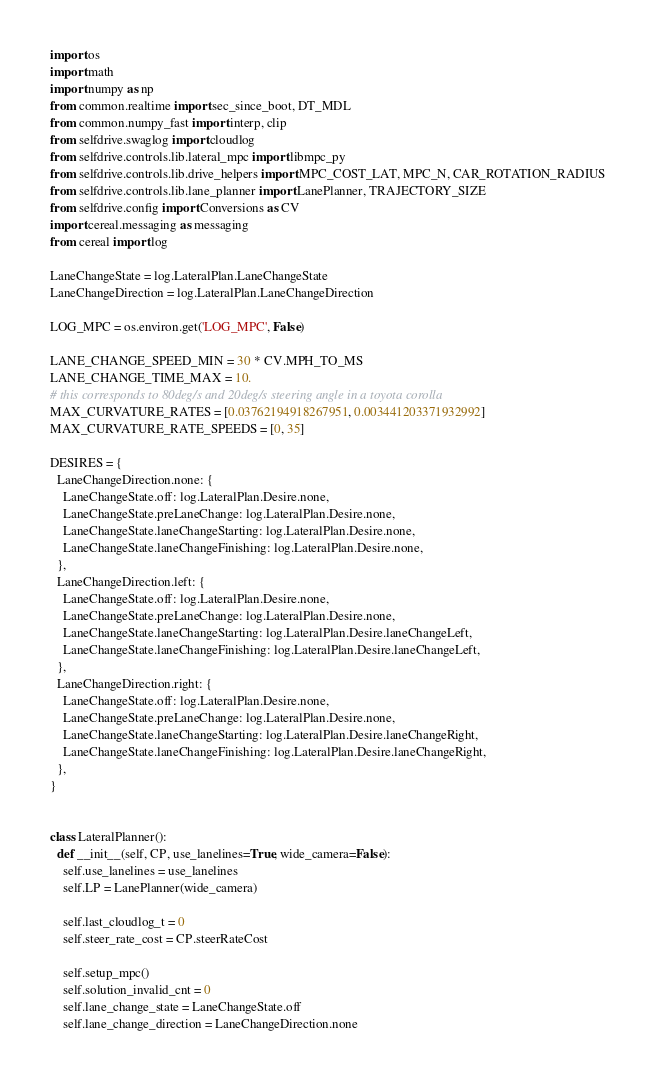Convert code to text. <code><loc_0><loc_0><loc_500><loc_500><_Python_>import os
import math
import numpy as np
from common.realtime import sec_since_boot, DT_MDL
from common.numpy_fast import interp, clip
from selfdrive.swaglog import cloudlog
from selfdrive.controls.lib.lateral_mpc import libmpc_py
from selfdrive.controls.lib.drive_helpers import MPC_COST_LAT, MPC_N, CAR_ROTATION_RADIUS
from selfdrive.controls.lib.lane_planner import LanePlanner, TRAJECTORY_SIZE
from selfdrive.config import Conversions as CV
import cereal.messaging as messaging
from cereal import log

LaneChangeState = log.LateralPlan.LaneChangeState
LaneChangeDirection = log.LateralPlan.LaneChangeDirection

LOG_MPC = os.environ.get('LOG_MPC', False)

LANE_CHANGE_SPEED_MIN = 30 * CV.MPH_TO_MS
LANE_CHANGE_TIME_MAX = 10.
# this corresponds to 80deg/s and 20deg/s steering angle in a toyota corolla
MAX_CURVATURE_RATES = [0.03762194918267951, 0.003441203371932992]
MAX_CURVATURE_RATE_SPEEDS = [0, 35]

DESIRES = {
  LaneChangeDirection.none: {
    LaneChangeState.off: log.LateralPlan.Desire.none,
    LaneChangeState.preLaneChange: log.LateralPlan.Desire.none,
    LaneChangeState.laneChangeStarting: log.LateralPlan.Desire.none,
    LaneChangeState.laneChangeFinishing: log.LateralPlan.Desire.none,
  },
  LaneChangeDirection.left: {
    LaneChangeState.off: log.LateralPlan.Desire.none,
    LaneChangeState.preLaneChange: log.LateralPlan.Desire.none,
    LaneChangeState.laneChangeStarting: log.LateralPlan.Desire.laneChangeLeft,
    LaneChangeState.laneChangeFinishing: log.LateralPlan.Desire.laneChangeLeft,
  },
  LaneChangeDirection.right: {
    LaneChangeState.off: log.LateralPlan.Desire.none,
    LaneChangeState.preLaneChange: log.LateralPlan.Desire.none,
    LaneChangeState.laneChangeStarting: log.LateralPlan.Desire.laneChangeRight,
    LaneChangeState.laneChangeFinishing: log.LateralPlan.Desire.laneChangeRight,
  },
}


class LateralPlanner():
  def __init__(self, CP, use_lanelines=True, wide_camera=False):
    self.use_lanelines = use_lanelines
    self.LP = LanePlanner(wide_camera)

    self.last_cloudlog_t = 0
    self.steer_rate_cost = CP.steerRateCost

    self.setup_mpc()
    self.solution_invalid_cnt = 0
    self.lane_change_state = LaneChangeState.off
    self.lane_change_direction = LaneChangeDirection.none</code> 